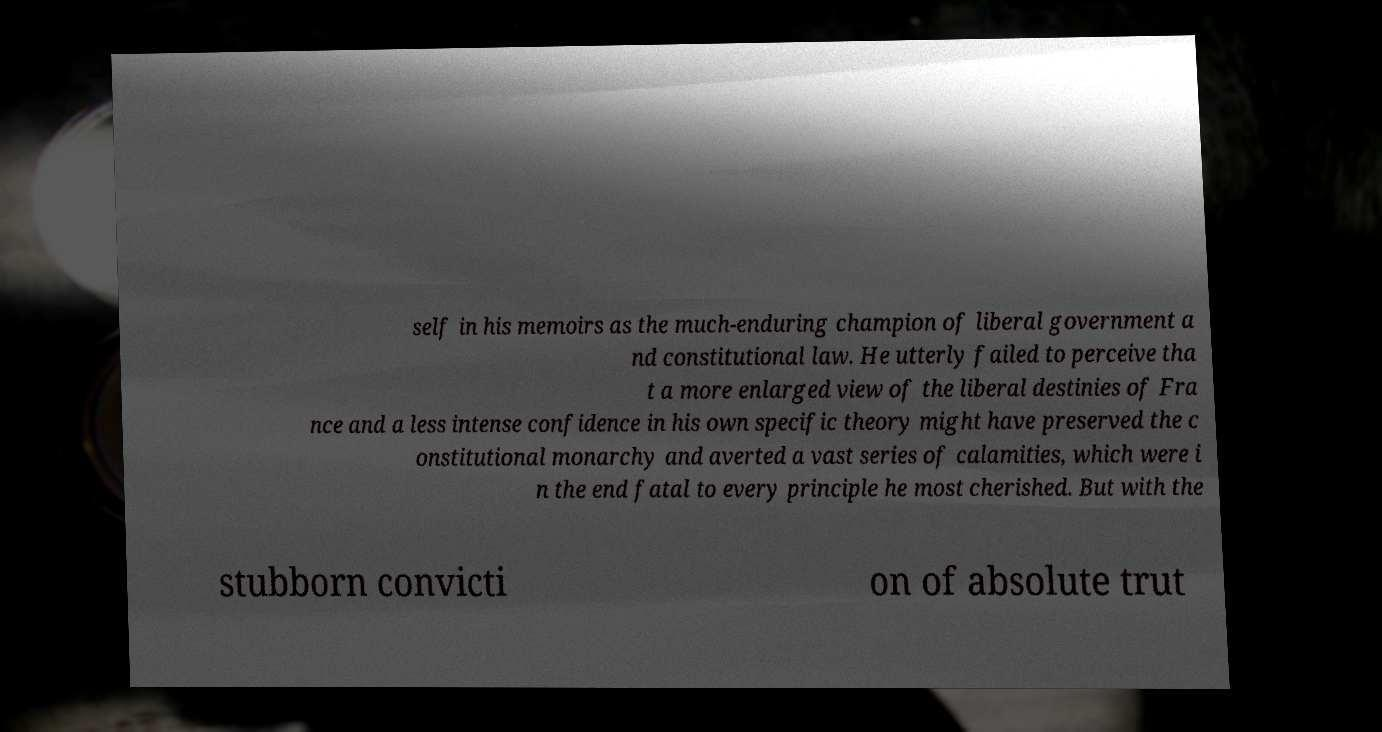There's text embedded in this image that I need extracted. Can you transcribe it verbatim? self in his memoirs as the much-enduring champion of liberal government a nd constitutional law. He utterly failed to perceive tha t a more enlarged view of the liberal destinies of Fra nce and a less intense confidence in his own specific theory might have preserved the c onstitutional monarchy and averted a vast series of calamities, which were i n the end fatal to every principle he most cherished. But with the stubborn convicti on of absolute trut 